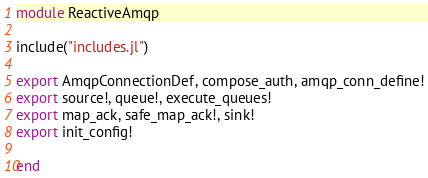Convert code to text. <code><loc_0><loc_0><loc_500><loc_500><_Julia_>module ReactiveAmqp

include("includes.jl")

export AmqpConnectionDef, compose_auth, amqp_conn_define!
export source!, queue!, execute_queues!
export map_ack, safe_map_ack!, sink!
export init_config!

end
</code> 